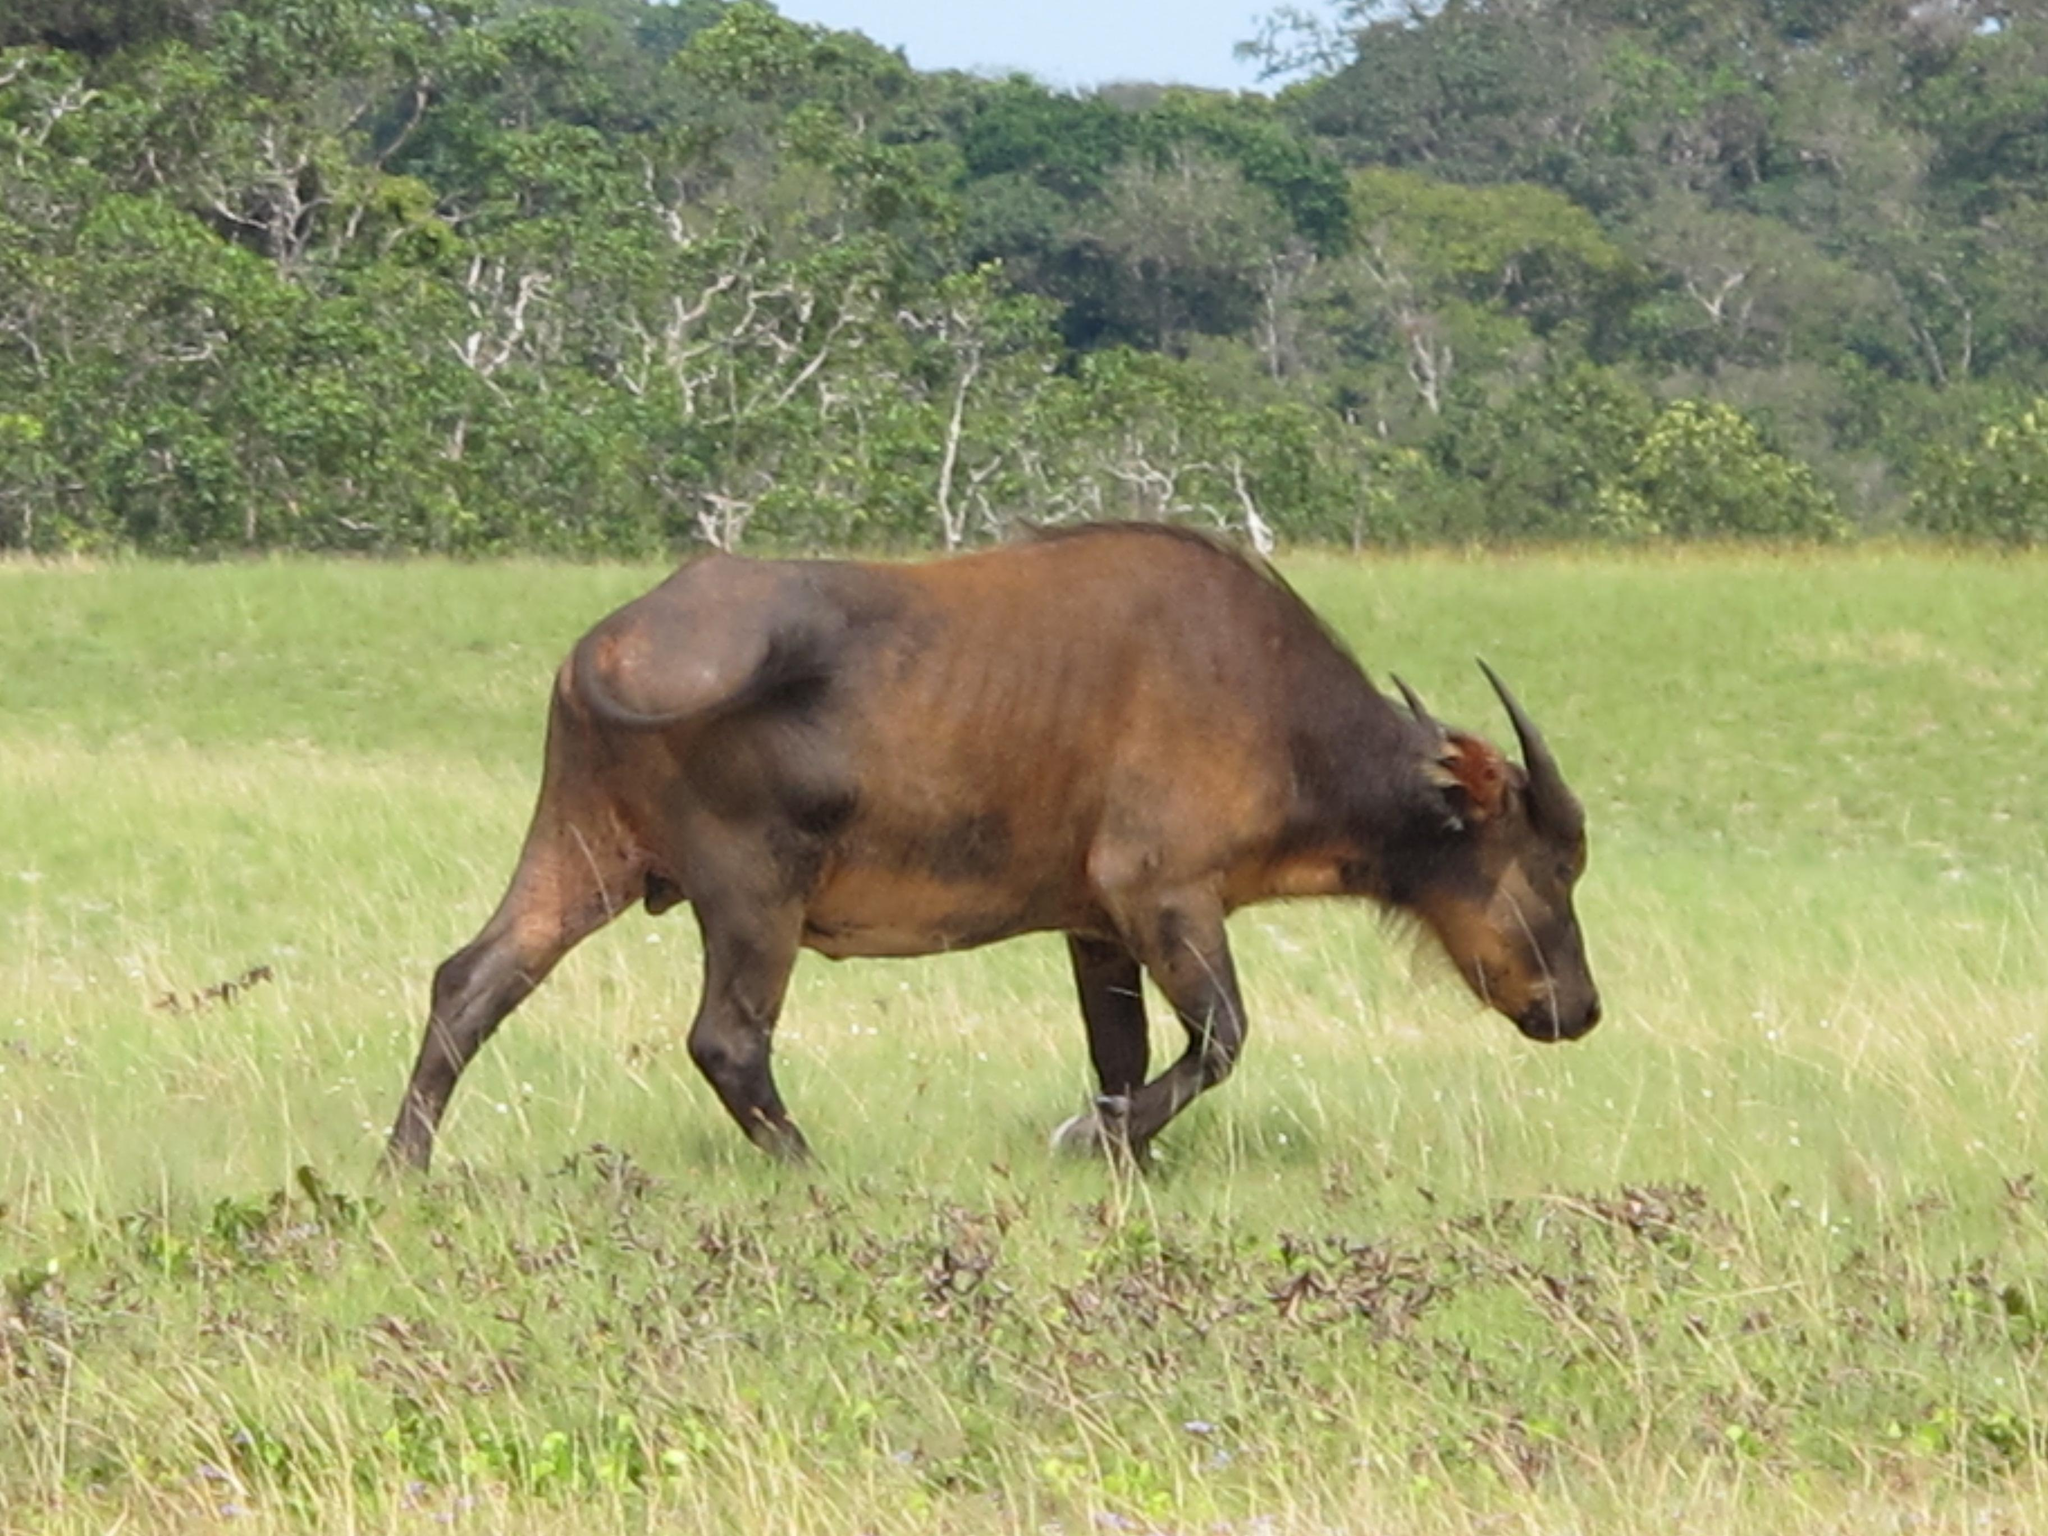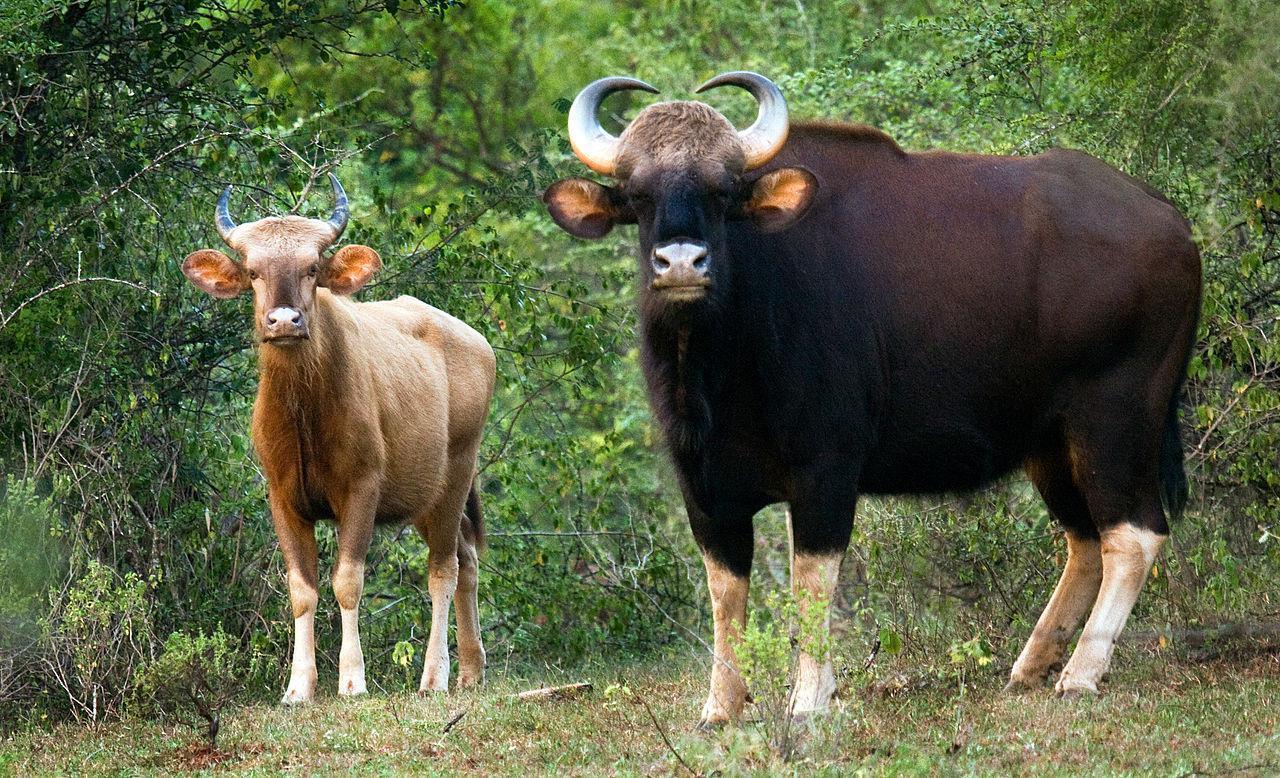The first image is the image on the left, the second image is the image on the right. For the images displayed, is the sentence "At least two brown animals are facing forward." factually correct? Answer yes or no. Yes. The first image is the image on the left, the second image is the image on the right. Assess this claim about the two images: "Right image contains at least twice as many horned animals as the left image.". Correct or not? Answer yes or no. Yes. 